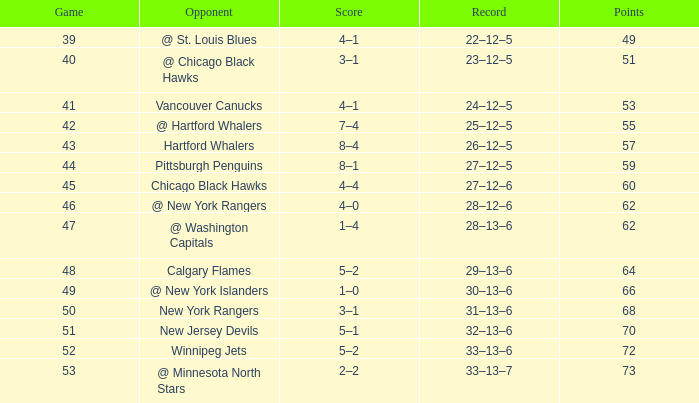How many games have a Score of 1–0, and Points smaller than 66? 0.0. 